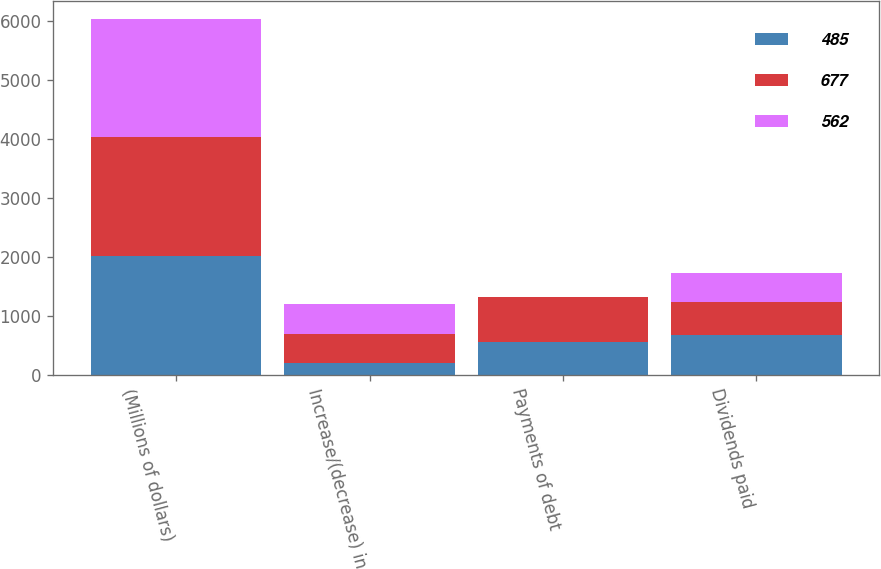Convert chart to OTSL. <chart><loc_0><loc_0><loc_500><loc_500><stacked_bar_chart><ecel><fcel>(Millions of dollars)<fcel>Increase/(decrease) in<fcel>Payments of debt<fcel>Dividends paid<nl><fcel>485<fcel>2017<fcel>200<fcel>562<fcel>677<nl><fcel>677<fcel>2016<fcel>500<fcel>752<fcel>562<nl><fcel>562<fcel>2015<fcel>500<fcel>6<fcel>485<nl></chart> 